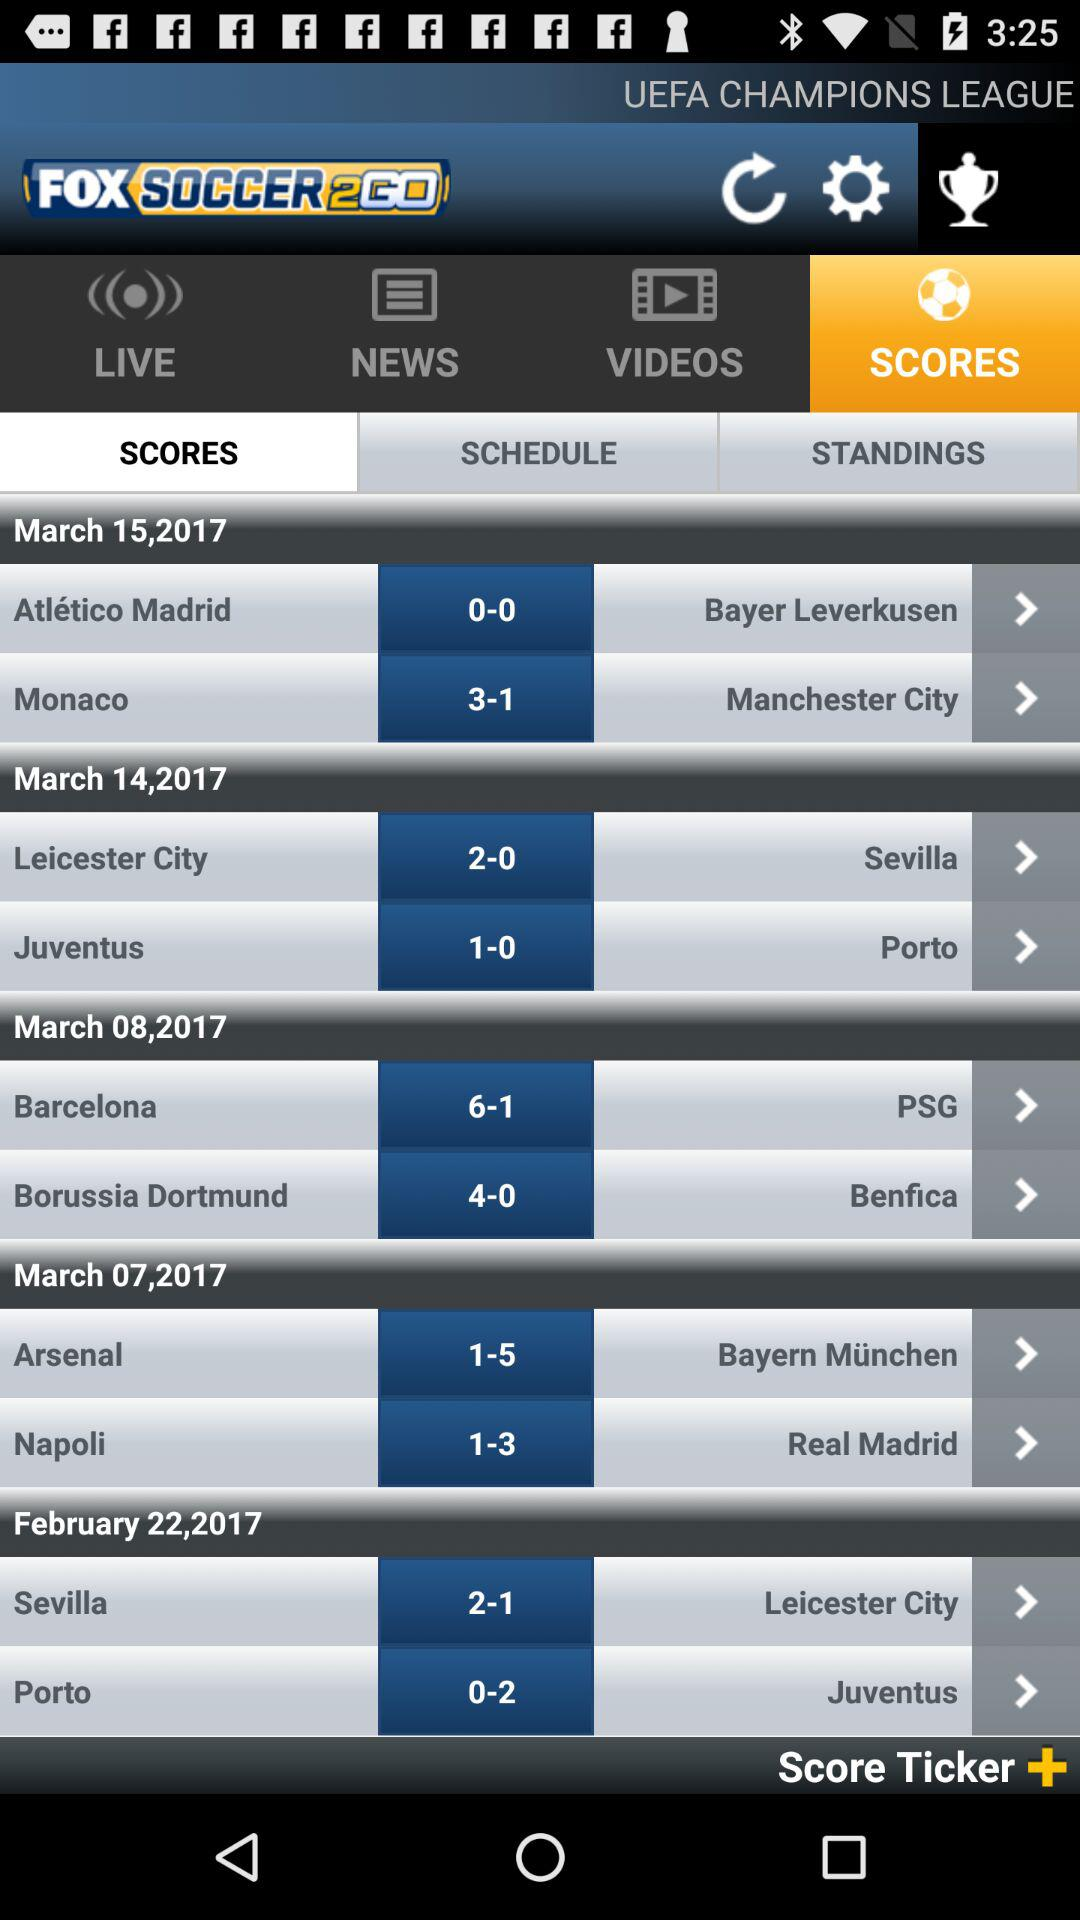What is the score between "Barcelona" and "PSG"? The score is 6-1. 